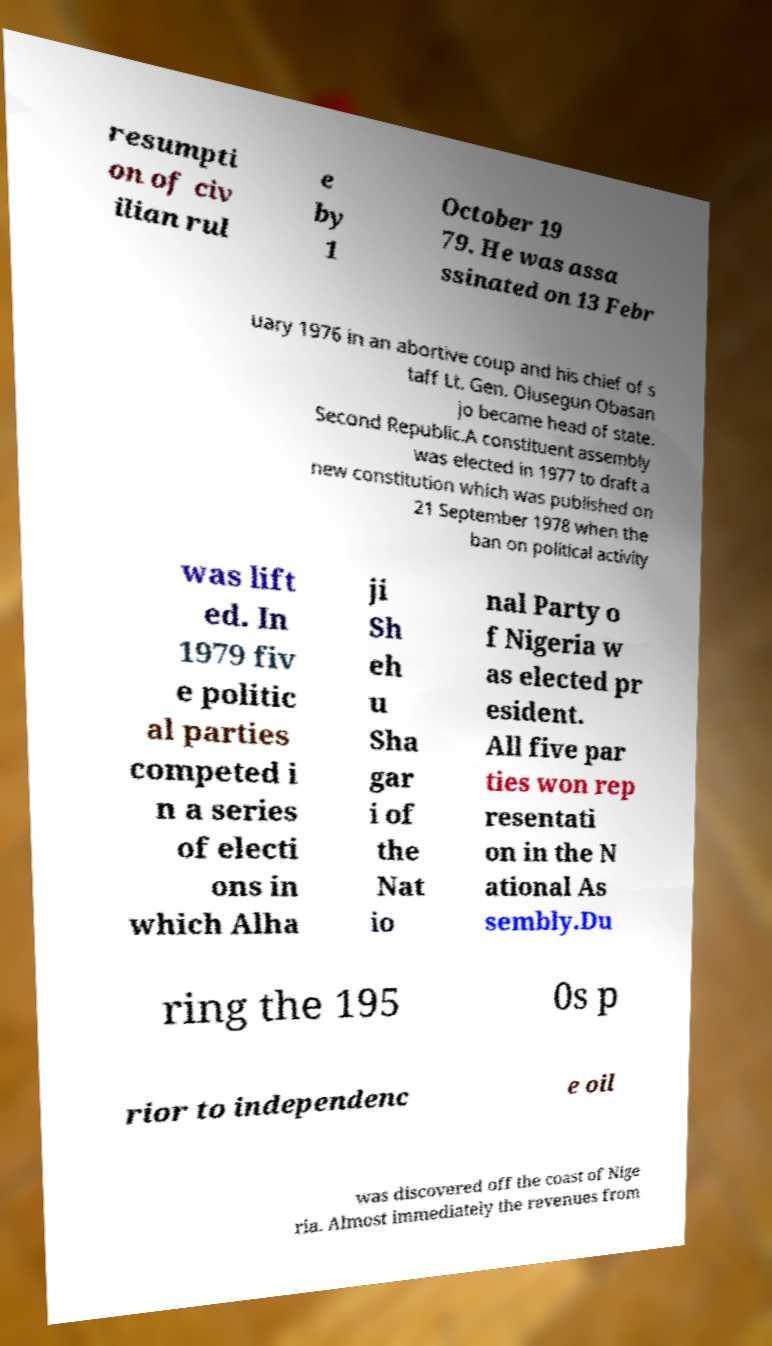Please identify and transcribe the text found in this image. resumpti on of civ ilian rul e by 1 October 19 79. He was assa ssinated on 13 Febr uary 1976 in an abortive coup and his chief of s taff Lt. Gen. Olusegun Obasan jo became head of state. Second Republic.A constituent assembly was elected in 1977 to draft a new constitution which was published on 21 September 1978 when the ban on political activity was lift ed. In 1979 fiv e politic al parties competed i n a series of electi ons in which Alha ji Sh eh u Sha gar i of the Nat io nal Party o f Nigeria w as elected pr esident. All five par ties won rep resentati on in the N ational As sembly.Du ring the 195 0s p rior to independenc e oil was discovered off the coast of Nige ria. Almost immediately the revenues from 